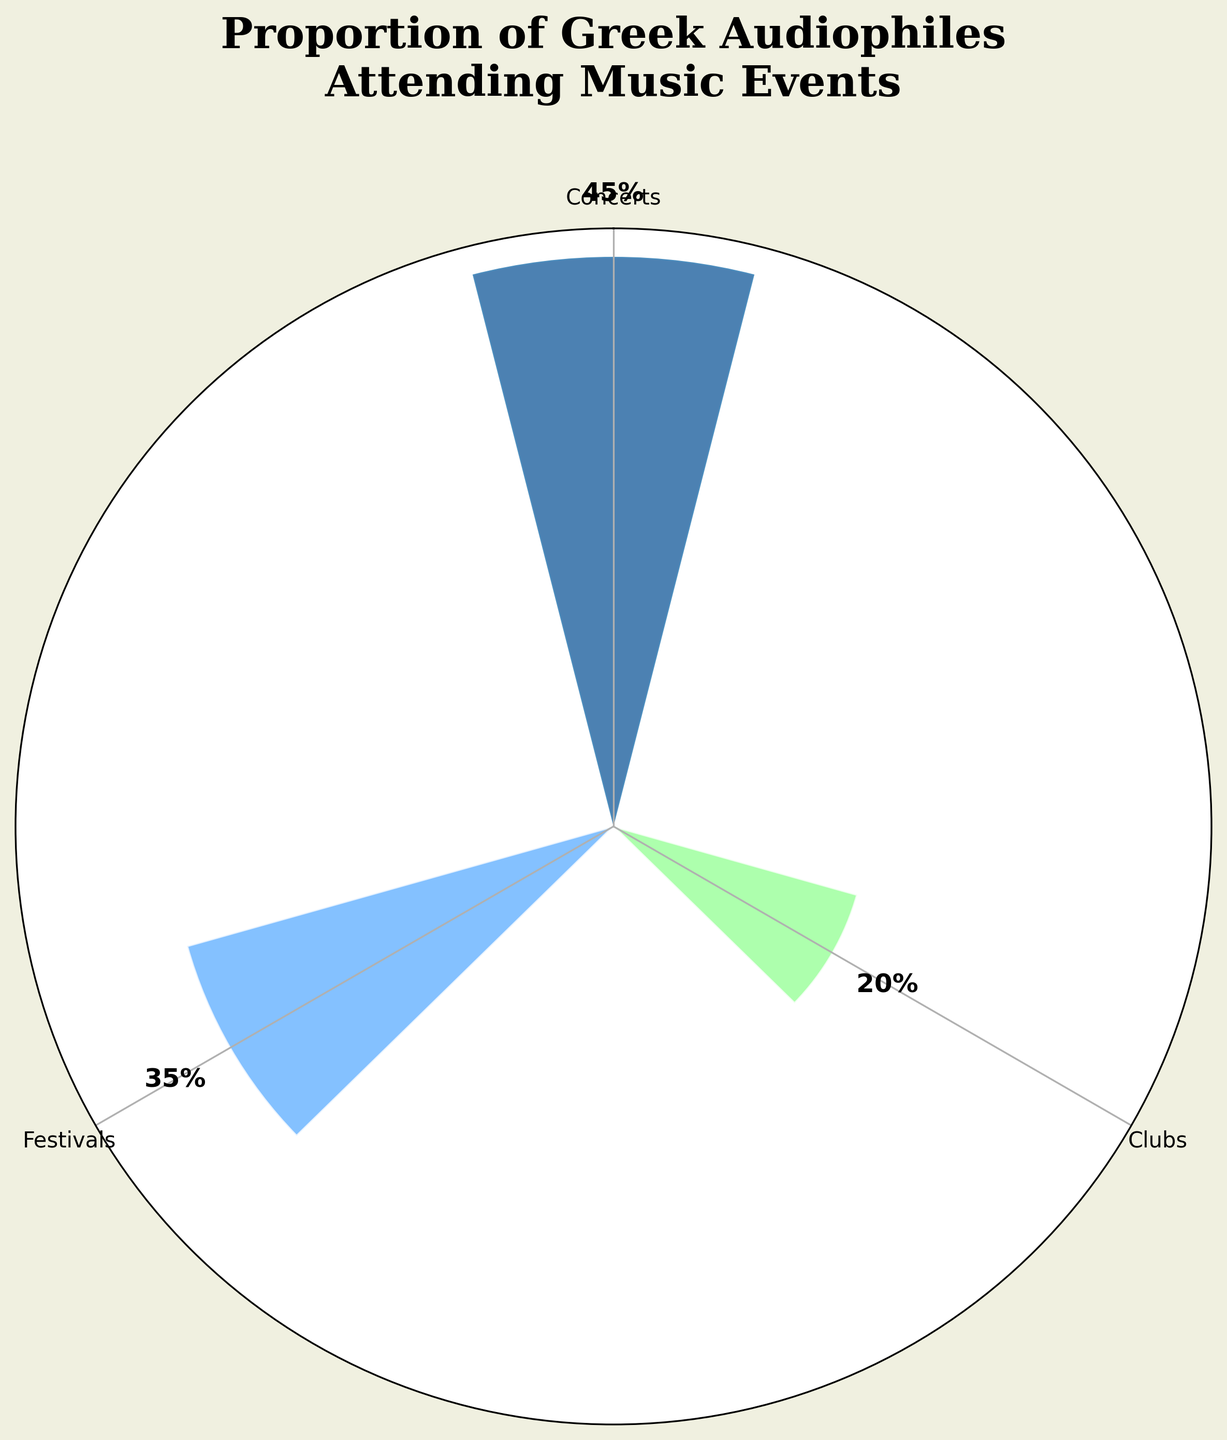What is the title of the plot? The title is displayed at the top of the plot and reads "Proportion of Greek Audiophiles Attending Music Events".
Answer: Proportion of Greek Audiophiles Attending Music Events Which type of music event has the highest proportion? By looking at the plot, the bar with the largest radius and labeled percentage is for Concerts at 45%.
Answer: Concerts How many music event categories are displayed in the rose chart? The rose chart shows three distinct bars corresponding to Concerts, Festivals, and Clubs.
Answer: Three What is the sum of proportions for Festivals and Clubs? The proportions for Festivals and Clubs are 35% and 20%, respectively. Adding them together gives 35 + 20 = 55.
Answer: 55% Which event types have proportions greater than 30%? From the plot, only Concerts and Festivals have proportions over 30%, which are 45% and 35%.
Answer: Concerts, Festivals Are there any event types with proportions less than 25%? Examining the plot, the Clubs category has a proportion of 20%, which is less than 25%.
Answer: Yes, Clubs What proportion of Greek audiophiles attend Festivals? The sector for Festivals is labeled with a 35% value on the plot.
Answer: 35% Which event has the smallest proportion of Greek audiophiles attending it? The smallest proportion shown on the plot is for Clubs, at 20%.
Answer: Clubs What is the proportion difference between Concerts and Festivals? The proportion for Concerts is 45% and for Festivals is 35%. The difference is 45 - 35 = 10%.
Answer: 10% By how much is the proportion of audiophiles attending Concerts greater than Clubs? The proportion of attending Concerts is 45%, and for Clubs, it is 20%. The difference is 45 - 20 = 25%.
Answer: 25% 